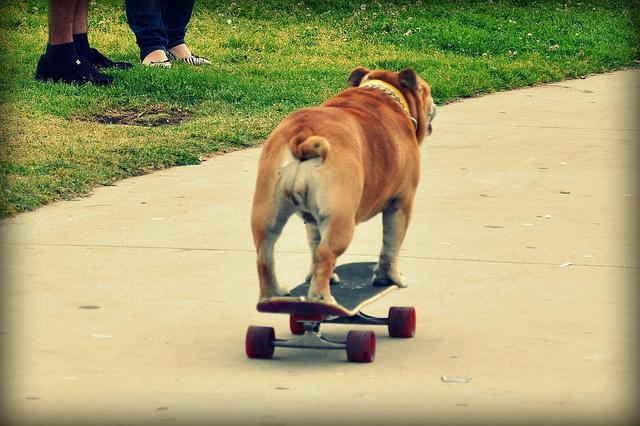Can this dog crush the skateboard?
Concise answer only. No. Is the dog riding a skateboard?
Answer briefly. Yes. Does the skateboard belong to its rider?
Keep it brief. No. Is this dog skateboarding?
Quick response, please. Yes. What kind of dog is this?
Answer briefly. Bulldog. 